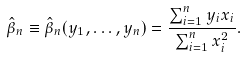Convert formula to latex. <formula><loc_0><loc_0><loc_500><loc_500>\hat { \beta } _ { n } \equiv \hat { \beta } _ { n } ( y _ { 1 } , \dots , y _ { n } ) = \frac { \sum _ { i = 1 } ^ { n } y _ { i } x _ { i } } { \sum _ { i = 1 } ^ { n } x _ { i } ^ { 2 } } .</formula> 